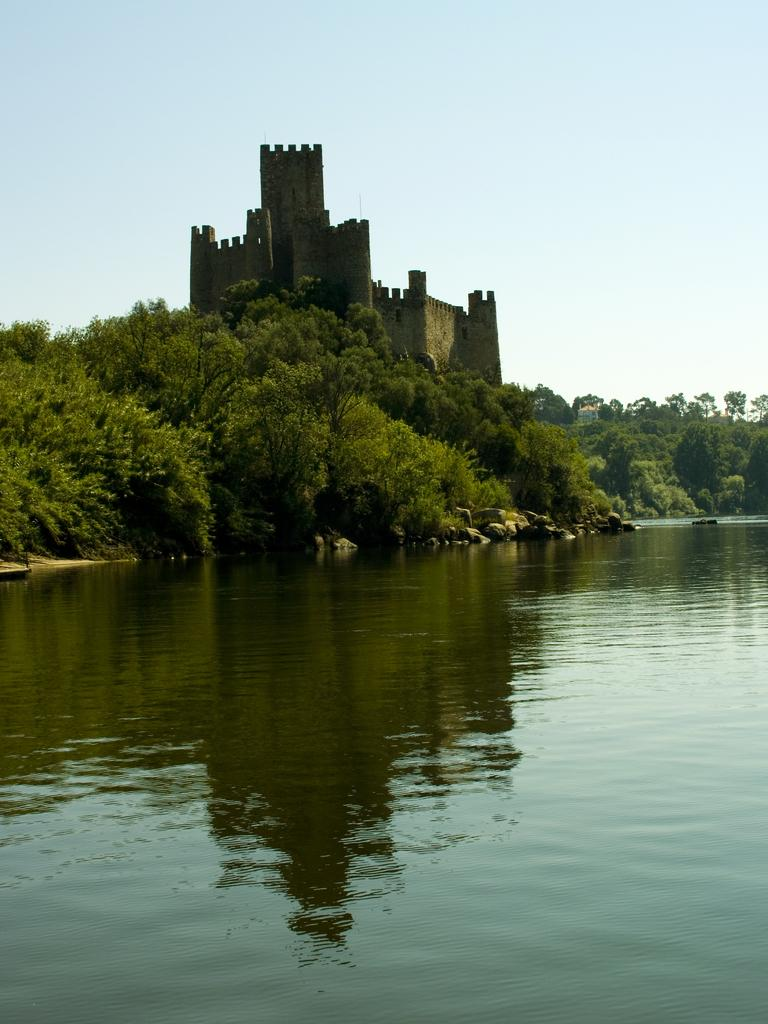What type of natural body of water is present in the image? There is a lake in the image. What is visible at the top of the image? The sky is visible at the top of the image. What type of vegetation can be seen in the image? There are trees in the image. What type of man-made structure is present in the image? There is a building in the image. What type of instrument is being played by the rabbits in the image? There are no rabbits or instruments present in the image. 